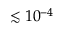<formula> <loc_0><loc_0><loc_500><loc_500>\lesssim 1 0 ^ { - 4 }</formula> 